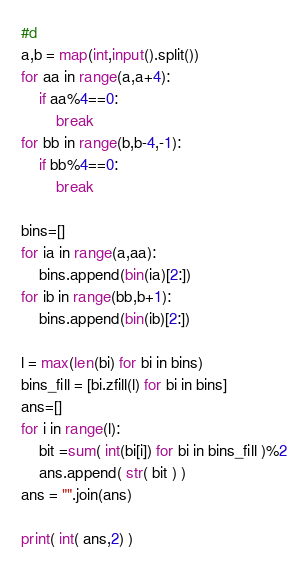<code> <loc_0><loc_0><loc_500><loc_500><_Python_>#d
a,b = map(int,input().split())
for aa in range(a,a+4):
    if aa%4==0:
        break
for bb in range(b,b-4,-1):
    if bb%4==0:
        break

bins=[]
for ia in range(a,aa):
    bins.append(bin(ia)[2:])
for ib in range(bb,b+1):
    bins.append(bin(ib)[2:])
    
l = max(len(bi) for bi in bins)
bins_fill = [bi.zfill(l) for bi in bins]
ans=[]
for i in range(l):
    bit =sum( int(bi[i]) for bi in bins_fill )%2
    ans.append( str( bit ) )
ans = "".join(ans)

print( int( ans,2) )</code> 